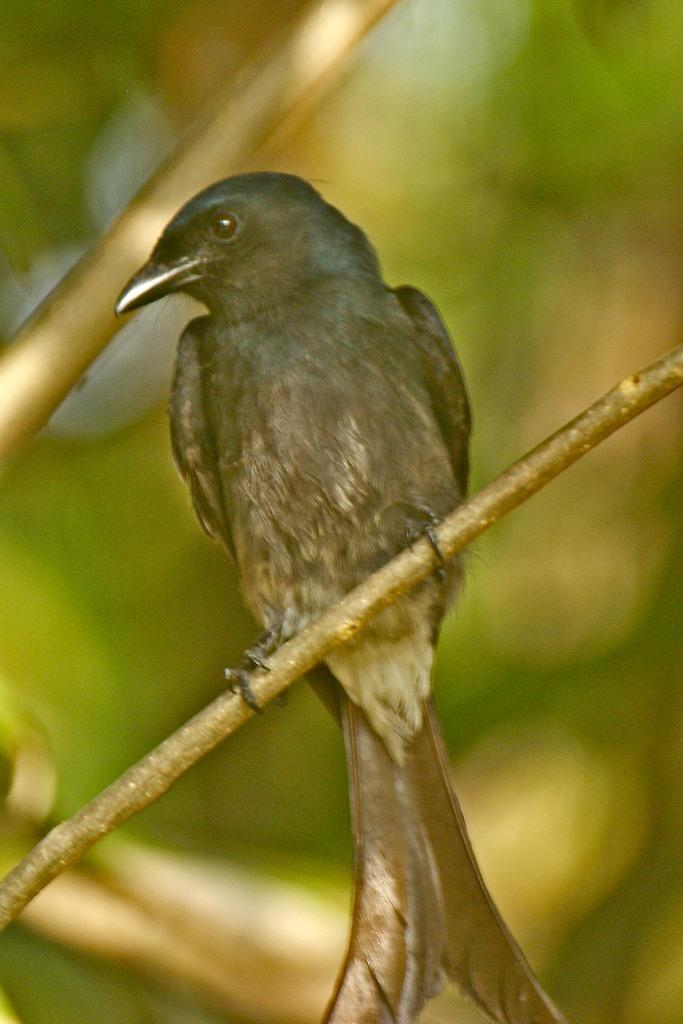What type of animal is in the image? There is a bird in the image. Where is the bird located in the image? The bird is on a stem. What type of holiday is being celebrated in the image? There is no indication of a holiday being celebrated in the image, as it only features a bird on a stem. What time of day is depicted in the image? The time of day is not specified in the image, as it only features a bird on a stem. 